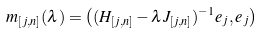Convert formula to latex. <formula><loc_0><loc_0><loc_500><loc_500>m _ { [ j , n ] } ( \lambda ) = \left ( ( H _ { [ j , n ] } - \lambda J _ { [ j , n ] } ) ^ { - 1 } e _ { j } , e _ { j } \right )</formula> 